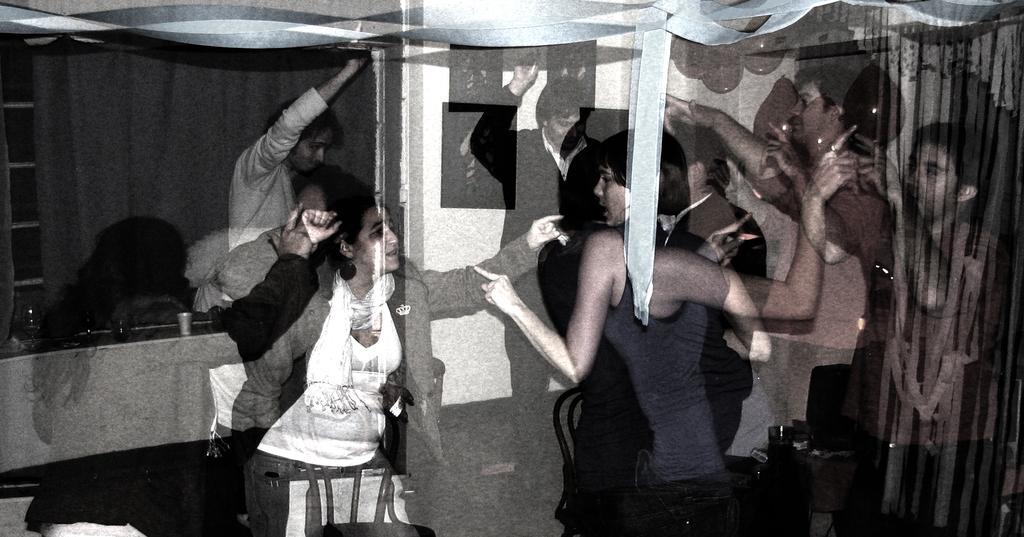How would you summarize this image in a sentence or two? This image consists of few people. It looks like they are dancing. And we can see the reflection in this image. On the right, there are curtains. In the background, we can see a window along with the curtain. And there is a table on which there are glasses. 